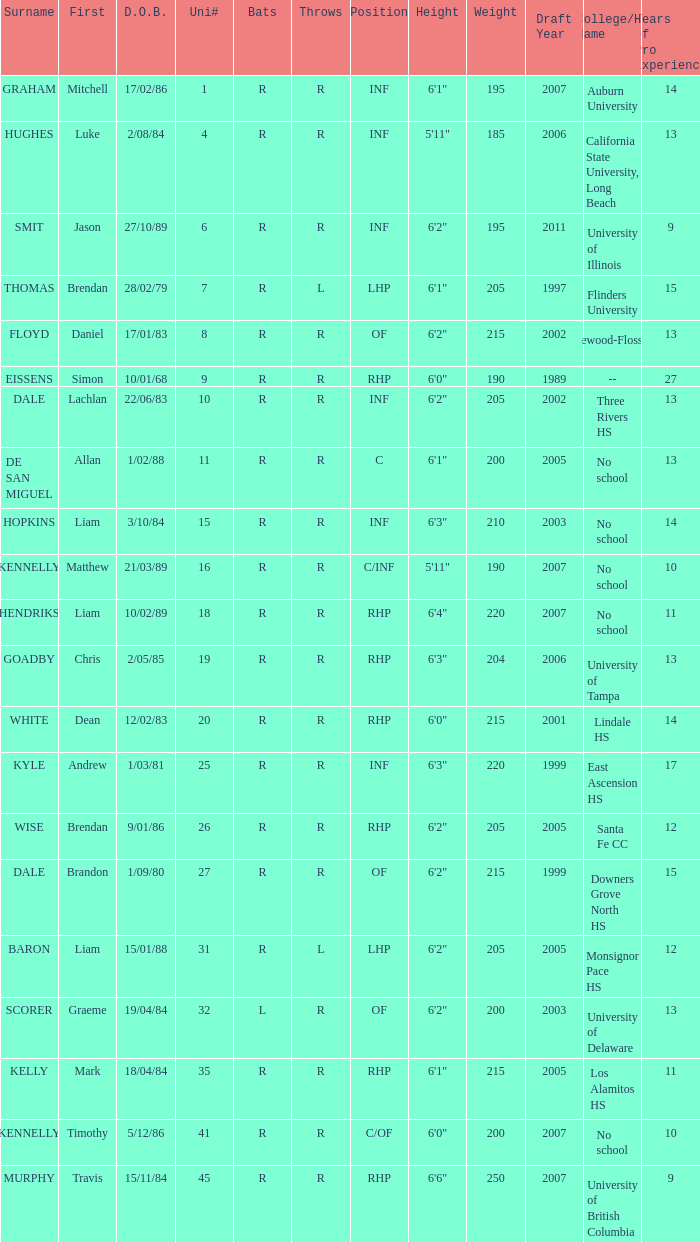Which player has a last name of baron? R. 